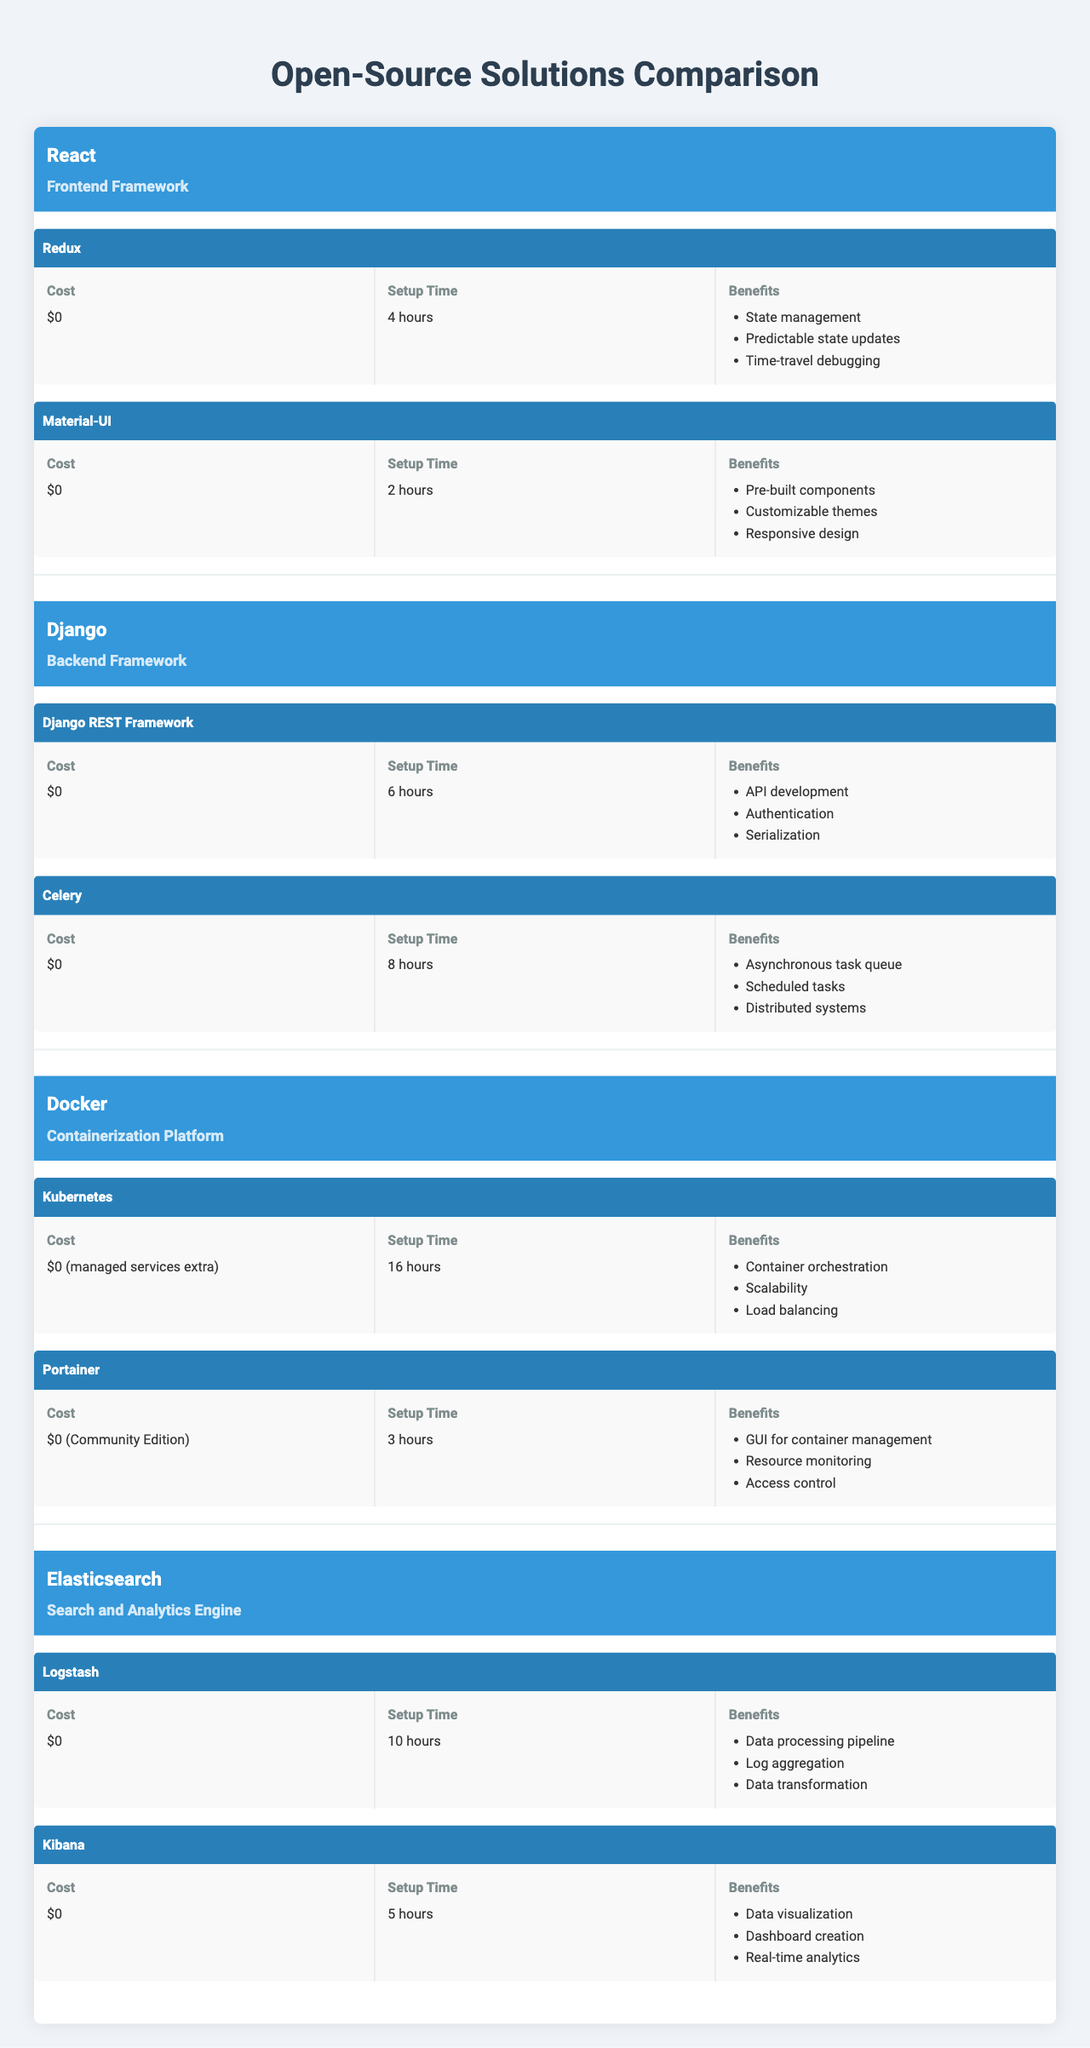What is the setup time for the Redux integration in React? The table shows the integration details for Redux under the React framework, which states that it requires a setup time of 4 hours.
Answer: 4 hours Which open-source solution has the longest setup time for any of its integrations? The table lists the setup times for all integrations. Docker's Kubernetes integration has the longest setup time of 16 hours, which is longer than any other integration's setup time.
Answer: Docker Do all integrations across the solutions have a cost of $0? By examining each integration listed in the table, it's evident that all integrations indeed have a cost of $0, with the exception of Docker's Kubernetes integration that states it has additional costs for managed services.
Answer: No How many benefits does the Material-UI integration provide? The table details that Material-UI offers three specific benefits: Pre-built components, Customizable themes, and Responsive design. Counting these gives a total of 3 benefits.
Answer: 3 Does the Django REST Framework integration have more benefits than the Celery integration? The benefits listed for Django REST Framework are API development, Authentication, and Serialization (3 benefits), while Celery lists Asynchronous task queue, Scheduled tasks, and Distributed systems (3 benefits). Both have the same number of benefits.
Answer: No Which integration, between Kibana and Material-UI, has a shorter setup time? The setup time for Kibana is 5 hours while Material-UI has a setup time of only 2 hours. Comparing these two times shows that Material-UI is quicker to set up.
Answer: Material-UI What are the total number of benefits provided by Elasticsearch's integrations? Elasticsearch has two integrations (Logstash and Kibana). Logstash has 3 benefits and Kibana has 3 benefits as well. Adding these (3 + 3) gives a total of 6 benefits across both integrations.
Answer: 6 Which open-source solution's integration is specifically for API development? The table identifies the Django REST Framework integration under the Django solution, which is specifically for API development.
Answer: Django Is it true that all integrations in the Docker solutions involve a user interface? The table shows Portainer provides a GUI, however, Kubernetes is focused on container orchestration and does not indicate a user interface in the description. Hence, this statement cannot be considered true.
Answer: No Among all integrations listed, which one has the least setup time? The integration details indicate that Material-UI has the least setup time at 2 hours compared to all others listed in the table.
Answer: Material-UI What is the average setup time for all integrations available across the open-source solutions? The setup times for all integrations are: Redux (4 hours), Material-UI (2 hours), Django REST Framework (6 hours), Celery (8 hours), Kubernetes (16 hours), and Portainer (3 hours), totaling 39 hours. Dividing by the 6 integrations gives an average of 6.5 hours.
Answer: 6.5 hours 